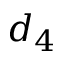Convert formula to latex. <formula><loc_0><loc_0><loc_500><loc_500>d _ { 4 }</formula> 